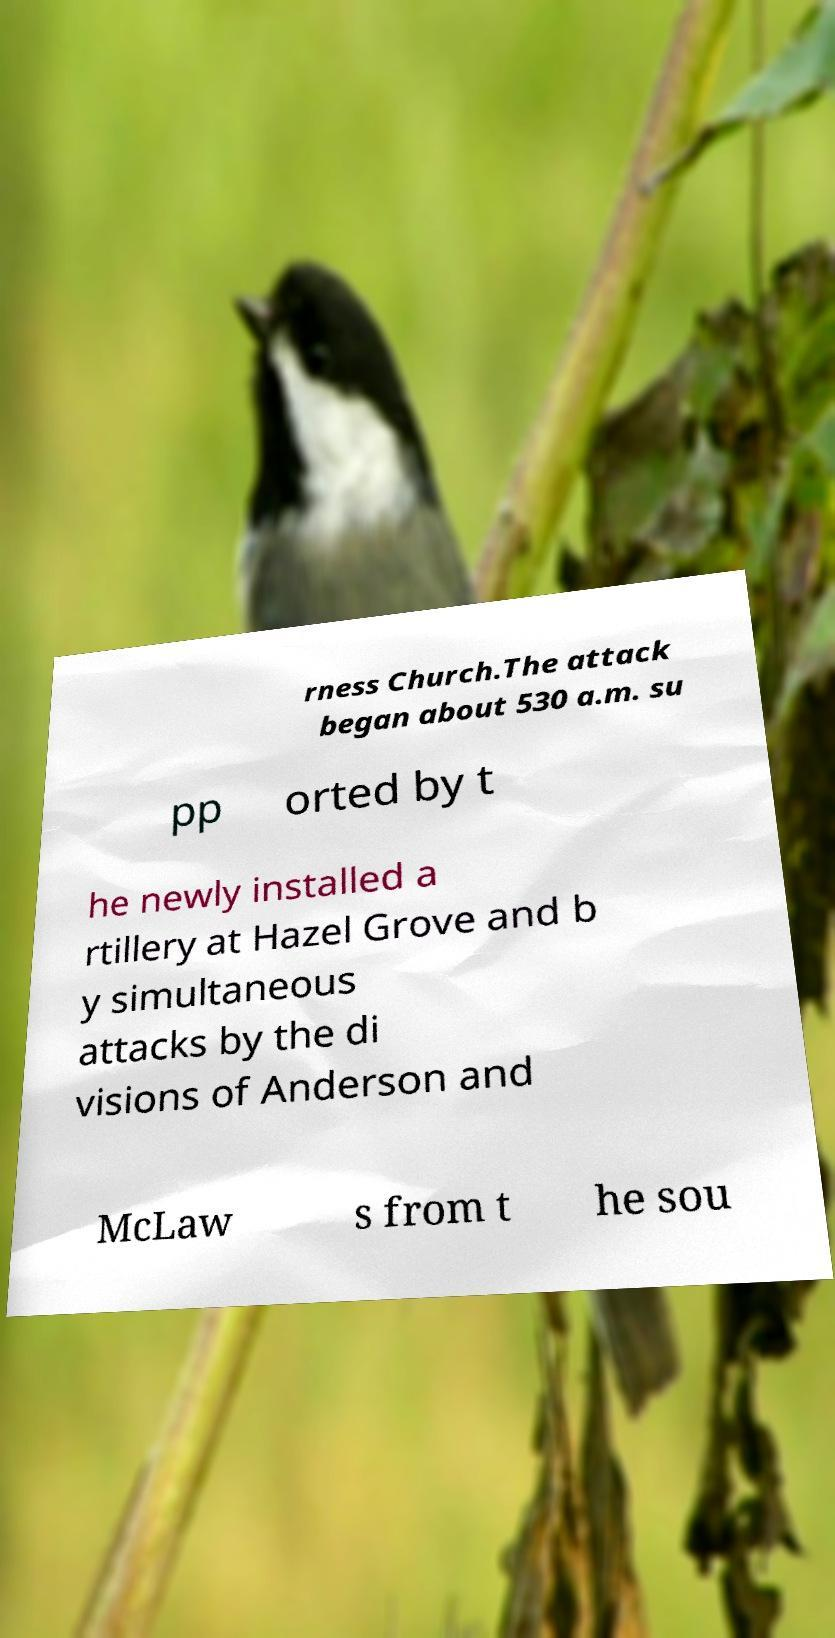There's text embedded in this image that I need extracted. Can you transcribe it verbatim? rness Church.The attack began about 530 a.m. su pp orted by t he newly installed a rtillery at Hazel Grove and b y simultaneous attacks by the di visions of Anderson and McLaw s from t he sou 